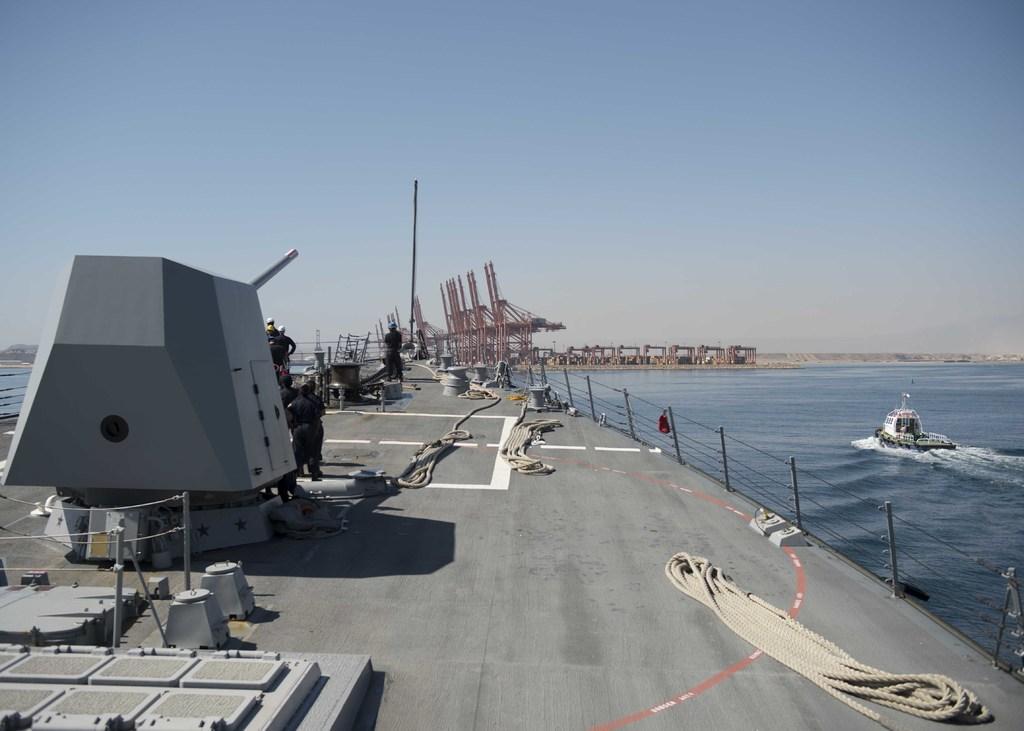How would you summarize this image in a sentence or two? In this picture we can see there are groups of people on the ship and on the ship there are ropes, fence and other items. On the right side of the ship there is a boat on the water. In front of the ship there are some objects and a sky. 